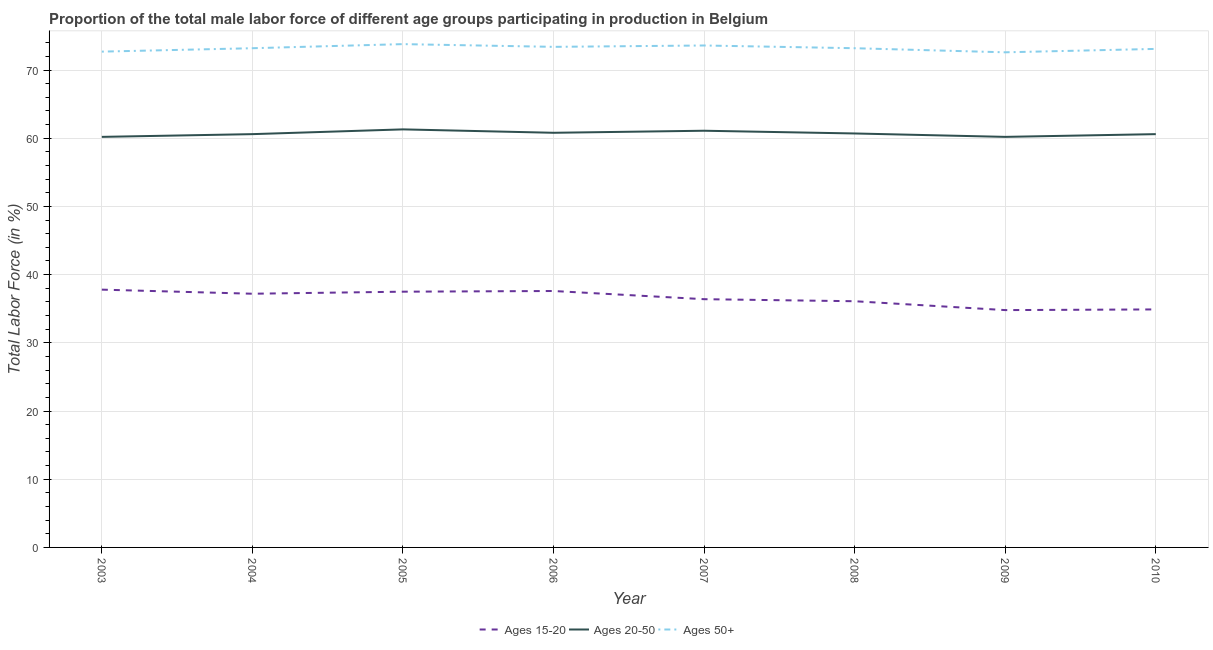How many different coloured lines are there?
Make the answer very short. 3. Does the line corresponding to percentage of male labor force within the age group 15-20 intersect with the line corresponding to percentage of male labor force above age 50?
Give a very brief answer. No. What is the percentage of male labor force above age 50 in 2007?
Ensure brevity in your answer.  73.6. Across all years, what is the maximum percentage of male labor force within the age group 15-20?
Make the answer very short. 37.8. Across all years, what is the minimum percentage of male labor force within the age group 20-50?
Provide a short and direct response. 60.2. In which year was the percentage of male labor force above age 50 maximum?
Give a very brief answer. 2005. What is the total percentage of male labor force within the age group 20-50 in the graph?
Make the answer very short. 485.5. What is the difference between the percentage of male labor force within the age group 20-50 in 2004 and that in 2008?
Your response must be concise. -0.1. What is the difference between the percentage of male labor force within the age group 20-50 in 2010 and the percentage of male labor force above age 50 in 2008?
Your answer should be compact. -12.6. What is the average percentage of male labor force within the age group 15-20 per year?
Ensure brevity in your answer.  36.54. In the year 2004, what is the difference between the percentage of male labor force within the age group 15-20 and percentage of male labor force within the age group 20-50?
Make the answer very short. -23.4. In how many years, is the percentage of male labor force within the age group 20-50 greater than 18 %?
Provide a short and direct response. 8. What is the ratio of the percentage of male labor force within the age group 15-20 in 2008 to that in 2010?
Your response must be concise. 1.03. Is the difference between the percentage of male labor force within the age group 15-20 in 2003 and 2007 greater than the difference between the percentage of male labor force within the age group 20-50 in 2003 and 2007?
Your response must be concise. Yes. What is the difference between the highest and the second highest percentage of male labor force within the age group 20-50?
Offer a very short reply. 0.2. What is the difference between the highest and the lowest percentage of male labor force above age 50?
Your answer should be compact. 1.2. Is the sum of the percentage of male labor force above age 50 in 2004 and 2006 greater than the maximum percentage of male labor force within the age group 20-50 across all years?
Ensure brevity in your answer.  Yes. Is it the case that in every year, the sum of the percentage of male labor force within the age group 15-20 and percentage of male labor force within the age group 20-50 is greater than the percentage of male labor force above age 50?
Ensure brevity in your answer.  Yes. Does the percentage of male labor force within the age group 20-50 monotonically increase over the years?
Provide a short and direct response. No. Is the percentage of male labor force within the age group 20-50 strictly greater than the percentage of male labor force above age 50 over the years?
Your answer should be very brief. No. How many lines are there?
Offer a terse response. 3. Are the values on the major ticks of Y-axis written in scientific E-notation?
Offer a very short reply. No. Does the graph contain any zero values?
Keep it short and to the point. No. Does the graph contain grids?
Make the answer very short. Yes. How are the legend labels stacked?
Offer a terse response. Horizontal. What is the title of the graph?
Provide a succinct answer. Proportion of the total male labor force of different age groups participating in production in Belgium. What is the label or title of the Y-axis?
Offer a very short reply. Total Labor Force (in %). What is the Total Labor Force (in %) of Ages 15-20 in 2003?
Provide a succinct answer. 37.8. What is the Total Labor Force (in %) of Ages 20-50 in 2003?
Your answer should be compact. 60.2. What is the Total Labor Force (in %) in Ages 50+ in 2003?
Your answer should be very brief. 72.7. What is the Total Labor Force (in %) of Ages 15-20 in 2004?
Make the answer very short. 37.2. What is the Total Labor Force (in %) in Ages 20-50 in 2004?
Your answer should be very brief. 60.6. What is the Total Labor Force (in %) in Ages 50+ in 2004?
Your response must be concise. 73.2. What is the Total Labor Force (in %) in Ages 15-20 in 2005?
Offer a terse response. 37.5. What is the Total Labor Force (in %) in Ages 20-50 in 2005?
Offer a very short reply. 61.3. What is the Total Labor Force (in %) of Ages 50+ in 2005?
Your answer should be compact. 73.8. What is the Total Labor Force (in %) of Ages 15-20 in 2006?
Ensure brevity in your answer.  37.6. What is the Total Labor Force (in %) of Ages 20-50 in 2006?
Your response must be concise. 60.8. What is the Total Labor Force (in %) in Ages 50+ in 2006?
Make the answer very short. 73.4. What is the Total Labor Force (in %) of Ages 15-20 in 2007?
Offer a terse response. 36.4. What is the Total Labor Force (in %) in Ages 20-50 in 2007?
Your response must be concise. 61.1. What is the Total Labor Force (in %) in Ages 50+ in 2007?
Ensure brevity in your answer.  73.6. What is the Total Labor Force (in %) of Ages 15-20 in 2008?
Your answer should be very brief. 36.1. What is the Total Labor Force (in %) in Ages 20-50 in 2008?
Your response must be concise. 60.7. What is the Total Labor Force (in %) in Ages 50+ in 2008?
Provide a short and direct response. 73.2. What is the Total Labor Force (in %) of Ages 15-20 in 2009?
Offer a terse response. 34.8. What is the Total Labor Force (in %) in Ages 20-50 in 2009?
Ensure brevity in your answer.  60.2. What is the Total Labor Force (in %) of Ages 50+ in 2009?
Provide a short and direct response. 72.6. What is the Total Labor Force (in %) in Ages 15-20 in 2010?
Offer a terse response. 34.9. What is the Total Labor Force (in %) of Ages 20-50 in 2010?
Offer a terse response. 60.6. What is the Total Labor Force (in %) in Ages 50+ in 2010?
Give a very brief answer. 73.1. Across all years, what is the maximum Total Labor Force (in %) of Ages 15-20?
Your answer should be compact. 37.8. Across all years, what is the maximum Total Labor Force (in %) of Ages 20-50?
Give a very brief answer. 61.3. Across all years, what is the maximum Total Labor Force (in %) in Ages 50+?
Make the answer very short. 73.8. Across all years, what is the minimum Total Labor Force (in %) in Ages 15-20?
Ensure brevity in your answer.  34.8. Across all years, what is the minimum Total Labor Force (in %) of Ages 20-50?
Offer a terse response. 60.2. Across all years, what is the minimum Total Labor Force (in %) in Ages 50+?
Your response must be concise. 72.6. What is the total Total Labor Force (in %) in Ages 15-20 in the graph?
Provide a succinct answer. 292.3. What is the total Total Labor Force (in %) in Ages 20-50 in the graph?
Your answer should be very brief. 485.5. What is the total Total Labor Force (in %) of Ages 50+ in the graph?
Offer a very short reply. 585.6. What is the difference between the Total Labor Force (in %) of Ages 15-20 in 2003 and that in 2004?
Give a very brief answer. 0.6. What is the difference between the Total Labor Force (in %) in Ages 50+ in 2003 and that in 2004?
Make the answer very short. -0.5. What is the difference between the Total Labor Force (in %) in Ages 20-50 in 2003 and that in 2005?
Your response must be concise. -1.1. What is the difference between the Total Labor Force (in %) of Ages 20-50 in 2003 and that in 2006?
Offer a terse response. -0.6. What is the difference between the Total Labor Force (in %) of Ages 50+ in 2003 and that in 2006?
Make the answer very short. -0.7. What is the difference between the Total Labor Force (in %) in Ages 15-20 in 2003 and that in 2007?
Keep it short and to the point. 1.4. What is the difference between the Total Labor Force (in %) of Ages 50+ in 2003 and that in 2007?
Provide a succinct answer. -0.9. What is the difference between the Total Labor Force (in %) of Ages 15-20 in 2003 and that in 2008?
Your answer should be very brief. 1.7. What is the difference between the Total Labor Force (in %) of Ages 50+ in 2003 and that in 2008?
Give a very brief answer. -0.5. What is the difference between the Total Labor Force (in %) in Ages 15-20 in 2003 and that in 2009?
Provide a short and direct response. 3. What is the difference between the Total Labor Force (in %) of Ages 50+ in 2003 and that in 2010?
Your answer should be very brief. -0.4. What is the difference between the Total Labor Force (in %) of Ages 20-50 in 2004 and that in 2006?
Your answer should be compact. -0.2. What is the difference between the Total Labor Force (in %) in Ages 50+ in 2004 and that in 2006?
Give a very brief answer. -0.2. What is the difference between the Total Labor Force (in %) of Ages 15-20 in 2004 and that in 2009?
Offer a terse response. 2.4. What is the difference between the Total Labor Force (in %) of Ages 50+ in 2004 and that in 2009?
Your answer should be compact. 0.6. What is the difference between the Total Labor Force (in %) of Ages 50+ in 2004 and that in 2010?
Offer a terse response. 0.1. What is the difference between the Total Labor Force (in %) in Ages 50+ in 2005 and that in 2007?
Give a very brief answer. 0.2. What is the difference between the Total Labor Force (in %) of Ages 15-20 in 2005 and that in 2008?
Offer a very short reply. 1.4. What is the difference between the Total Labor Force (in %) of Ages 20-50 in 2005 and that in 2009?
Give a very brief answer. 1.1. What is the difference between the Total Labor Force (in %) in Ages 50+ in 2005 and that in 2009?
Ensure brevity in your answer.  1.2. What is the difference between the Total Labor Force (in %) of Ages 15-20 in 2005 and that in 2010?
Provide a succinct answer. 2.6. What is the difference between the Total Labor Force (in %) of Ages 15-20 in 2006 and that in 2007?
Keep it short and to the point. 1.2. What is the difference between the Total Labor Force (in %) in Ages 20-50 in 2006 and that in 2007?
Keep it short and to the point. -0.3. What is the difference between the Total Labor Force (in %) of Ages 50+ in 2006 and that in 2007?
Make the answer very short. -0.2. What is the difference between the Total Labor Force (in %) of Ages 15-20 in 2006 and that in 2009?
Your response must be concise. 2.8. What is the difference between the Total Labor Force (in %) of Ages 50+ in 2006 and that in 2009?
Your answer should be very brief. 0.8. What is the difference between the Total Labor Force (in %) in Ages 50+ in 2006 and that in 2010?
Ensure brevity in your answer.  0.3. What is the difference between the Total Labor Force (in %) of Ages 20-50 in 2007 and that in 2008?
Offer a very short reply. 0.4. What is the difference between the Total Labor Force (in %) in Ages 15-20 in 2007 and that in 2009?
Keep it short and to the point. 1.6. What is the difference between the Total Labor Force (in %) in Ages 20-50 in 2007 and that in 2009?
Offer a terse response. 0.9. What is the difference between the Total Labor Force (in %) of Ages 50+ in 2007 and that in 2009?
Your answer should be very brief. 1. What is the difference between the Total Labor Force (in %) of Ages 20-50 in 2007 and that in 2010?
Give a very brief answer. 0.5. What is the difference between the Total Labor Force (in %) in Ages 50+ in 2007 and that in 2010?
Your answer should be very brief. 0.5. What is the difference between the Total Labor Force (in %) in Ages 20-50 in 2008 and that in 2009?
Ensure brevity in your answer.  0.5. What is the difference between the Total Labor Force (in %) of Ages 50+ in 2008 and that in 2009?
Keep it short and to the point. 0.6. What is the difference between the Total Labor Force (in %) in Ages 15-20 in 2008 and that in 2010?
Your response must be concise. 1.2. What is the difference between the Total Labor Force (in %) of Ages 20-50 in 2008 and that in 2010?
Keep it short and to the point. 0.1. What is the difference between the Total Labor Force (in %) of Ages 50+ in 2008 and that in 2010?
Provide a short and direct response. 0.1. What is the difference between the Total Labor Force (in %) in Ages 15-20 in 2009 and that in 2010?
Offer a very short reply. -0.1. What is the difference between the Total Labor Force (in %) in Ages 15-20 in 2003 and the Total Labor Force (in %) in Ages 20-50 in 2004?
Provide a succinct answer. -22.8. What is the difference between the Total Labor Force (in %) of Ages 15-20 in 2003 and the Total Labor Force (in %) of Ages 50+ in 2004?
Your answer should be very brief. -35.4. What is the difference between the Total Labor Force (in %) of Ages 15-20 in 2003 and the Total Labor Force (in %) of Ages 20-50 in 2005?
Offer a terse response. -23.5. What is the difference between the Total Labor Force (in %) of Ages 15-20 in 2003 and the Total Labor Force (in %) of Ages 50+ in 2005?
Provide a short and direct response. -36. What is the difference between the Total Labor Force (in %) in Ages 15-20 in 2003 and the Total Labor Force (in %) in Ages 20-50 in 2006?
Your answer should be very brief. -23. What is the difference between the Total Labor Force (in %) in Ages 15-20 in 2003 and the Total Labor Force (in %) in Ages 50+ in 2006?
Keep it short and to the point. -35.6. What is the difference between the Total Labor Force (in %) of Ages 20-50 in 2003 and the Total Labor Force (in %) of Ages 50+ in 2006?
Make the answer very short. -13.2. What is the difference between the Total Labor Force (in %) in Ages 15-20 in 2003 and the Total Labor Force (in %) in Ages 20-50 in 2007?
Your response must be concise. -23.3. What is the difference between the Total Labor Force (in %) in Ages 15-20 in 2003 and the Total Labor Force (in %) in Ages 50+ in 2007?
Provide a succinct answer. -35.8. What is the difference between the Total Labor Force (in %) of Ages 15-20 in 2003 and the Total Labor Force (in %) of Ages 20-50 in 2008?
Offer a terse response. -22.9. What is the difference between the Total Labor Force (in %) of Ages 15-20 in 2003 and the Total Labor Force (in %) of Ages 50+ in 2008?
Keep it short and to the point. -35.4. What is the difference between the Total Labor Force (in %) of Ages 20-50 in 2003 and the Total Labor Force (in %) of Ages 50+ in 2008?
Make the answer very short. -13. What is the difference between the Total Labor Force (in %) of Ages 15-20 in 2003 and the Total Labor Force (in %) of Ages 20-50 in 2009?
Offer a very short reply. -22.4. What is the difference between the Total Labor Force (in %) of Ages 15-20 in 2003 and the Total Labor Force (in %) of Ages 50+ in 2009?
Offer a very short reply. -34.8. What is the difference between the Total Labor Force (in %) in Ages 20-50 in 2003 and the Total Labor Force (in %) in Ages 50+ in 2009?
Your answer should be very brief. -12.4. What is the difference between the Total Labor Force (in %) of Ages 15-20 in 2003 and the Total Labor Force (in %) of Ages 20-50 in 2010?
Your answer should be very brief. -22.8. What is the difference between the Total Labor Force (in %) of Ages 15-20 in 2003 and the Total Labor Force (in %) of Ages 50+ in 2010?
Offer a terse response. -35.3. What is the difference between the Total Labor Force (in %) in Ages 20-50 in 2003 and the Total Labor Force (in %) in Ages 50+ in 2010?
Give a very brief answer. -12.9. What is the difference between the Total Labor Force (in %) of Ages 15-20 in 2004 and the Total Labor Force (in %) of Ages 20-50 in 2005?
Provide a succinct answer. -24.1. What is the difference between the Total Labor Force (in %) in Ages 15-20 in 2004 and the Total Labor Force (in %) in Ages 50+ in 2005?
Provide a succinct answer. -36.6. What is the difference between the Total Labor Force (in %) of Ages 15-20 in 2004 and the Total Labor Force (in %) of Ages 20-50 in 2006?
Your answer should be compact. -23.6. What is the difference between the Total Labor Force (in %) of Ages 15-20 in 2004 and the Total Labor Force (in %) of Ages 50+ in 2006?
Keep it short and to the point. -36.2. What is the difference between the Total Labor Force (in %) in Ages 15-20 in 2004 and the Total Labor Force (in %) in Ages 20-50 in 2007?
Make the answer very short. -23.9. What is the difference between the Total Labor Force (in %) of Ages 15-20 in 2004 and the Total Labor Force (in %) of Ages 50+ in 2007?
Offer a very short reply. -36.4. What is the difference between the Total Labor Force (in %) in Ages 15-20 in 2004 and the Total Labor Force (in %) in Ages 20-50 in 2008?
Your response must be concise. -23.5. What is the difference between the Total Labor Force (in %) of Ages 15-20 in 2004 and the Total Labor Force (in %) of Ages 50+ in 2008?
Provide a succinct answer. -36. What is the difference between the Total Labor Force (in %) of Ages 20-50 in 2004 and the Total Labor Force (in %) of Ages 50+ in 2008?
Offer a terse response. -12.6. What is the difference between the Total Labor Force (in %) of Ages 15-20 in 2004 and the Total Labor Force (in %) of Ages 50+ in 2009?
Offer a terse response. -35.4. What is the difference between the Total Labor Force (in %) in Ages 15-20 in 2004 and the Total Labor Force (in %) in Ages 20-50 in 2010?
Give a very brief answer. -23.4. What is the difference between the Total Labor Force (in %) of Ages 15-20 in 2004 and the Total Labor Force (in %) of Ages 50+ in 2010?
Your answer should be compact. -35.9. What is the difference between the Total Labor Force (in %) of Ages 15-20 in 2005 and the Total Labor Force (in %) of Ages 20-50 in 2006?
Your answer should be compact. -23.3. What is the difference between the Total Labor Force (in %) of Ages 15-20 in 2005 and the Total Labor Force (in %) of Ages 50+ in 2006?
Offer a very short reply. -35.9. What is the difference between the Total Labor Force (in %) of Ages 15-20 in 2005 and the Total Labor Force (in %) of Ages 20-50 in 2007?
Keep it short and to the point. -23.6. What is the difference between the Total Labor Force (in %) in Ages 15-20 in 2005 and the Total Labor Force (in %) in Ages 50+ in 2007?
Keep it short and to the point. -36.1. What is the difference between the Total Labor Force (in %) in Ages 15-20 in 2005 and the Total Labor Force (in %) in Ages 20-50 in 2008?
Keep it short and to the point. -23.2. What is the difference between the Total Labor Force (in %) in Ages 15-20 in 2005 and the Total Labor Force (in %) in Ages 50+ in 2008?
Offer a terse response. -35.7. What is the difference between the Total Labor Force (in %) of Ages 20-50 in 2005 and the Total Labor Force (in %) of Ages 50+ in 2008?
Your response must be concise. -11.9. What is the difference between the Total Labor Force (in %) in Ages 15-20 in 2005 and the Total Labor Force (in %) in Ages 20-50 in 2009?
Offer a very short reply. -22.7. What is the difference between the Total Labor Force (in %) of Ages 15-20 in 2005 and the Total Labor Force (in %) of Ages 50+ in 2009?
Offer a very short reply. -35.1. What is the difference between the Total Labor Force (in %) in Ages 15-20 in 2005 and the Total Labor Force (in %) in Ages 20-50 in 2010?
Offer a terse response. -23.1. What is the difference between the Total Labor Force (in %) in Ages 15-20 in 2005 and the Total Labor Force (in %) in Ages 50+ in 2010?
Your answer should be compact. -35.6. What is the difference between the Total Labor Force (in %) of Ages 20-50 in 2005 and the Total Labor Force (in %) of Ages 50+ in 2010?
Keep it short and to the point. -11.8. What is the difference between the Total Labor Force (in %) of Ages 15-20 in 2006 and the Total Labor Force (in %) of Ages 20-50 in 2007?
Keep it short and to the point. -23.5. What is the difference between the Total Labor Force (in %) in Ages 15-20 in 2006 and the Total Labor Force (in %) in Ages 50+ in 2007?
Provide a succinct answer. -36. What is the difference between the Total Labor Force (in %) in Ages 20-50 in 2006 and the Total Labor Force (in %) in Ages 50+ in 2007?
Ensure brevity in your answer.  -12.8. What is the difference between the Total Labor Force (in %) of Ages 15-20 in 2006 and the Total Labor Force (in %) of Ages 20-50 in 2008?
Keep it short and to the point. -23.1. What is the difference between the Total Labor Force (in %) of Ages 15-20 in 2006 and the Total Labor Force (in %) of Ages 50+ in 2008?
Your answer should be compact. -35.6. What is the difference between the Total Labor Force (in %) in Ages 20-50 in 2006 and the Total Labor Force (in %) in Ages 50+ in 2008?
Provide a short and direct response. -12.4. What is the difference between the Total Labor Force (in %) in Ages 15-20 in 2006 and the Total Labor Force (in %) in Ages 20-50 in 2009?
Provide a short and direct response. -22.6. What is the difference between the Total Labor Force (in %) of Ages 15-20 in 2006 and the Total Labor Force (in %) of Ages 50+ in 2009?
Your answer should be very brief. -35. What is the difference between the Total Labor Force (in %) of Ages 20-50 in 2006 and the Total Labor Force (in %) of Ages 50+ in 2009?
Your answer should be very brief. -11.8. What is the difference between the Total Labor Force (in %) in Ages 15-20 in 2006 and the Total Labor Force (in %) in Ages 50+ in 2010?
Keep it short and to the point. -35.5. What is the difference between the Total Labor Force (in %) in Ages 15-20 in 2007 and the Total Labor Force (in %) in Ages 20-50 in 2008?
Your response must be concise. -24.3. What is the difference between the Total Labor Force (in %) of Ages 15-20 in 2007 and the Total Labor Force (in %) of Ages 50+ in 2008?
Provide a short and direct response. -36.8. What is the difference between the Total Labor Force (in %) in Ages 15-20 in 2007 and the Total Labor Force (in %) in Ages 20-50 in 2009?
Give a very brief answer. -23.8. What is the difference between the Total Labor Force (in %) of Ages 15-20 in 2007 and the Total Labor Force (in %) of Ages 50+ in 2009?
Keep it short and to the point. -36.2. What is the difference between the Total Labor Force (in %) in Ages 20-50 in 2007 and the Total Labor Force (in %) in Ages 50+ in 2009?
Make the answer very short. -11.5. What is the difference between the Total Labor Force (in %) of Ages 15-20 in 2007 and the Total Labor Force (in %) of Ages 20-50 in 2010?
Your response must be concise. -24.2. What is the difference between the Total Labor Force (in %) of Ages 15-20 in 2007 and the Total Labor Force (in %) of Ages 50+ in 2010?
Your answer should be very brief. -36.7. What is the difference between the Total Labor Force (in %) in Ages 15-20 in 2008 and the Total Labor Force (in %) in Ages 20-50 in 2009?
Your response must be concise. -24.1. What is the difference between the Total Labor Force (in %) in Ages 15-20 in 2008 and the Total Labor Force (in %) in Ages 50+ in 2009?
Make the answer very short. -36.5. What is the difference between the Total Labor Force (in %) of Ages 15-20 in 2008 and the Total Labor Force (in %) of Ages 20-50 in 2010?
Offer a terse response. -24.5. What is the difference between the Total Labor Force (in %) in Ages 15-20 in 2008 and the Total Labor Force (in %) in Ages 50+ in 2010?
Offer a terse response. -37. What is the difference between the Total Labor Force (in %) in Ages 20-50 in 2008 and the Total Labor Force (in %) in Ages 50+ in 2010?
Give a very brief answer. -12.4. What is the difference between the Total Labor Force (in %) in Ages 15-20 in 2009 and the Total Labor Force (in %) in Ages 20-50 in 2010?
Make the answer very short. -25.8. What is the difference between the Total Labor Force (in %) in Ages 15-20 in 2009 and the Total Labor Force (in %) in Ages 50+ in 2010?
Offer a terse response. -38.3. What is the average Total Labor Force (in %) in Ages 15-20 per year?
Provide a succinct answer. 36.54. What is the average Total Labor Force (in %) of Ages 20-50 per year?
Your answer should be very brief. 60.69. What is the average Total Labor Force (in %) in Ages 50+ per year?
Offer a very short reply. 73.2. In the year 2003, what is the difference between the Total Labor Force (in %) in Ages 15-20 and Total Labor Force (in %) in Ages 20-50?
Your answer should be compact. -22.4. In the year 2003, what is the difference between the Total Labor Force (in %) in Ages 15-20 and Total Labor Force (in %) in Ages 50+?
Offer a terse response. -34.9. In the year 2004, what is the difference between the Total Labor Force (in %) in Ages 15-20 and Total Labor Force (in %) in Ages 20-50?
Offer a very short reply. -23.4. In the year 2004, what is the difference between the Total Labor Force (in %) of Ages 15-20 and Total Labor Force (in %) of Ages 50+?
Offer a terse response. -36. In the year 2005, what is the difference between the Total Labor Force (in %) of Ages 15-20 and Total Labor Force (in %) of Ages 20-50?
Ensure brevity in your answer.  -23.8. In the year 2005, what is the difference between the Total Labor Force (in %) in Ages 15-20 and Total Labor Force (in %) in Ages 50+?
Ensure brevity in your answer.  -36.3. In the year 2005, what is the difference between the Total Labor Force (in %) of Ages 20-50 and Total Labor Force (in %) of Ages 50+?
Your answer should be compact. -12.5. In the year 2006, what is the difference between the Total Labor Force (in %) of Ages 15-20 and Total Labor Force (in %) of Ages 20-50?
Provide a succinct answer. -23.2. In the year 2006, what is the difference between the Total Labor Force (in %) of Ages 15-20 and Total Labor Force (in %) of Ages 50+?
Offer a very short reply. -35.8. In the year 2006, what is the difference between the Total Labor Force (in %) of Ages 20-50 and Total Labor Force (in %) of Ages 50+?
Give a very brief answer. -12.6. In the year 2007, what is the difference between the Total Labor Force (in %) in Ages 15-20 and Total Labor Force (in %) in Ages 20-50?
Offer a terse response. -24.7. In the year 2007, what is the difference between the Total Labor Force (in %) of Ages 15-20 and Total Labor Force (in %) of Ages 50+?
Your response must be concise. -37.2. In the year 2008, what is the difference between the Total Labor Force (in %) in Ages 15-20 and Total Labor Force (in %) in Ages 20-50?
Your response must be concise. -24.6. In the year 2008, what is the difference between the Total Labor Force (in %) of Ages 15-20 and Total Labor Force (in %) of Ages 50+?
Offer a very short reply. -37.1. In the year 2008, what is the difference between the Total Labor Force (in %) in Ages 20-50 and Total Labor Force (in %) in Ages 50+?
Give a very brief answer. -12.5. In the year 2009, what is the difference between the Total Labor Force (in %) of Ages 15-20 and Total Labor Force (in %) of Ages 20-50?
Your answer should be compact. -25.4. In the year 2009, what is the difference between the Total Labor Force (in %) of Ages 15-20 and Total Labor Force (in %) of Ages 50+?
Your answer should be very brief. -37.8. In the year 2009, what is the difference between the Total Labor Force (in %) in Ages 20-50 and Total Labor Force (in %) in Ages 50+?
Your answer should be very brief. -12.4. In the year 2010, what is the difference between the Total Labor Force (in %) in Ages 15-20 and Total Labor Force (in %) in Ages 20-50?
Provide a succinct answer. -25.7. In the year 2010, what is the difference between the Total Labor Force (in %) of Ages 15-20 and Total Labor Force (in %) of Ages 50+?
Keep it short and to the point. -38.2. In the year 2010, what is the difference between the Total Labor Force (in %) of Ages 20-50 and Total Labor Force (in %) of Ages 50+?
Your answer should be compact. -12.5. What is the ratio of the Total Labor Force (in %) of Ages 15-20 in 2003 to that in 2004?
Give a very brief answer. 1.02. What is the ratio of the Total Labor Force (in %) of Ages 20-50 in 2003 to that in 2004?
Keep it short and to the point. 0.99. What is the ratio of the Total Labor Force (in %) of Ages 50+ in 2003 to that in 2004?
Keep it short and to the point. 0.99. What is the ratio of the Total Labor Force (in %) in Ages 15-20 in 2003 to that in 2005?
Your answer should be very brief. 1.01. What is the ratio of the Total Labor Force (in %) in Ages 20-50 in 2003 to that in 2005?
Keep it short and to the point. 0.98. What is the ratio of the Total Labor Force (in %) of Ages 50+ in 2003 to that in 2005?
Keep it short and to the point. 0.99. What is the ratio of the Total Labor Force (in %) of Ages 15-20 in 2003 to that in 2006?
Your answer should be very brief. 1.01. What is the ratio of the Total Labor Force (in %) in Ages 15-20 in 2003 to that in 2007?
Your response must be concise. 1.04. What is the ratio of the Total Labor Force (in %) in Ages 20-50 in 2003 to that in 2007?
Offer a terse response. 0.99. What is the ratio of the Total Labor Force (in %) of Ages 15-20 in 2003 to that in 2008?
Keep it short and to the point. 1.05. What is the ratio of the Total Labor Force (in %) in Ages 20-50 in 2003 to that in 2008?
Offer a terse response. 0.99. What is the ratio of the Total Labor Force (in %) of Ages 50+ in 2003 to that in 2008?
Offer a very short reply. 0.99. What is the ratio of the Total Labor Force (in %) in Ages 15-20 in 2003 to that in 2009?
Keep it short and to the point. 1.09. What is the ratio of the Total Labor Force (in %) in Ages 15-20 in 2003 to that in 2010?
Keep it short and to the point. 1.08. What is the ratio of the Total Labor Force (in %) of Ages 20-50 in 2004 to that in 2005?
Provide a short and direct response. 0.99. What is the ratio of the Total Labor Force (in %) of Ages 50+ in 2004 to that in 2005?
Your response must be concise. 0.99. What is the ratio of the Total Labor Force (in %) in Ages 15-20 in 2004 to that in 2006?
Offer a very short reply. 0.99. What is the ratio of the Total Labor Force (in %) of Ages 50+ in 2004 to that in 2006?
Keep it short and to the point. 1. What is the ratio of the Total Labor Force (in %) in Ages 15-20 in 2004 to that in 2008?
Your response must be concise. 1.03. What is the ratio of the Total Labor Force (in %) in Ages 15-20 in 2004 to that in 2009?
Ensure brevity in your answer.  1.07. What is the ratio of the Total Labor Force (in %) of Ages 20-50 in 2004 to that in 2009?
Your response must be concise. 1.01. What is the ratio of the Total Labor Force (in %) of Ages 50+ in 2004 to that in 2009?
Offer a very short reply. 1.01. What is the ratio of the Total Labor Force (in %) of Ages 15-20 in 2004 to that in 2010?
Give a very brief answer. 1.07. What is the ratio of the Total Labor Force (in %) in Ages 20-50 in 2004 to that in 2010?
Provide a succinct answer. 1. What is the ratio of the Total Labor Force (in %) in Ages 50+ in 2004 to that in 2010?
Your answer should be very brief. 1. What is the ratio of the Total Labor Force (in %) of Ages 20-50 in 2005 to that in 2006?
Ensure brevity in your answer.  1.01. What is the ratio of the Total Labor Force (in %) of Ages 50+ in 2005 to that in 2006?
Make the answer very short. 1.01. What is the ratio of the Total Labor Force (in %) of Ages 15-20 in 2005 to that in 2007?
Provide a succinct answer. 1.03. What is the ratio of the Total Labor Force (in %) of Ages 20-50 in 2005 to that in 2007?
Ensure brevity in your answer.  1. What is the ratio of the Total Labor Force (in %) in Ages 50+ in 2005 to that in 2007?
Provide a short and direct response. 1. What is the ratio of the Total Labor Force (in %) in Ages 15-20 in 2005 to that in 2008?
Provide a short and direct response. 1.04. What is the ratio of the Total Labor Force (in %) in Ages 20-50 in 2005 to that in 2008?
Your response must be concise. 1.01. What is the ratio of the Total Labor Force (in %) of Ages 50+ in 2005 to that in 2008?
Provide a short and direct response. 1.01. What is the ratio of the Total Labor Force (in %) of Ages 15-20 in 2005 to that in 2009?
Provide a succinct answer. 1.08. What is the ratio of the Total Labor Force (in %) in Ages 20-50 in 2005 to that in 2009?
Your answer should be very brief. 1.02. What is the ratio of the Total Labor Force (in %) of Ages 50+ in 2005 to that in 2009?
Your response must be concise. 1.02. What is the ratio of the Total Labor Force (in %) in Ages 15-20 in 2005 to that in 2010?
Provide a short and direct response. 1.07. What is the ratio of the Total Labor Force (in %) in Ages 20-50 in 2005 to that in 2010?
Make the answer very short. 1.01. What is the ratio of the Total Labor Force (in %) in Ages 50+ in 2005 to that in 2010?
Make the answer very short. 1.01. What is the ratio of the Total Labor Force (in %) of Ages 15-20 in 2006 to that in 2007?
Make the answer very short. 1.03. What is the ratio of the Total Labor Force (in %) in Ages 50+ in 2006 to that in 2007?
Make the answer very short. 1. What is the ratio of the Total Labor Force (in %) of Ages 15-20 in 2006 to that in 2008?
Provide a succinct answer. 1.04. What is the ratio of the Total Labor Force (in %) in Ages 15-20 in 2006 to that in 2009?
Give a very brief answer. 1.08. What is the ratio of the Total Labor Force (in %) in Ages 15-20 in 2006 to that in 2010?
Give a very brief answer. 1.08. What is the ratio of the Total Labor Force (in %) of Ages 20-50 in 2006 to that in 2010?
Ensure brevity in your answer.  1. What is the ratio of the Total Labor Force (in %) of Ages 50+ in 2006 to that in 2010?
Your response must be concise. 1. What is the ratio of the Total Labor Force (in %) in Ages 15-20 in 2007 to that in 2008?
Give a very brief answer. 1.01. What is the ratio of the Total Labor Force (in %) of Ages 20-50 in 2007 to that in 2008?
Your answer should be very brief. 1.01. What is the ratio of the Total Labor Force (in %) of Ages 50+ in 2007 to that in 2008?
Provide a short and direct response. 1.01. What is the ratio of the Total Labor Force (in %) of Ages 15-20 in 2007 to that in 2009?
Ensure brevity in your answer.  1.05. What is the ratio of the Total Labor Force (in %) in Ages 20-50 in 2007 to that in 2009?
Offer a terse response. 1.01. What is the ratio of the Total Labor Force (in %) in Ages 50+ in 2007 to that in 2009?
Keep it short and to the point. 1.01. What is the ratio of the Total Labor Force (in %) in Ages 15-20 in 2007 to that in 2010?
Your answer should be compact. 1.04. What is the ratio of the Total Labor Force (in %) in Ages 20-50 in 2007 to that in 2010?
Give a very brief answer. 1.01. What is the ratio of the Total Labor Force (in %) in Ages 50+ in 2007 to that in 2010?
Your answer should be compact. 1.01. What is the ratio of the Total Labor Force (in %) in Ages 15-20 in 2008 to that in 2009?
Offer a very short reply. 1.04. What is the ratio of the Total Labor Force (in %) in Ages 20-50 in 2008 to that in 2009?
Your response must be concise. 1.01. What is the ratio of the Total Labor Force (in %) of Ages 50+ in 2008 to that in 2009?
Your answer should be very brief. 1.01. What is the ratio of the Total Labor Force (in %) in Ages 15-20 in 2008 to that in 2010?
Keep it short and to the point. 1.03. What is the ratio of the Total Labor Force (in %) in Ages 50+ in 2008 to that in 2010?
Keep it short and to the point. 1. What is the difference between the highest and the second highest Total Labor Force (in %) of Ages 15-20?
Your answer should be compact. 0.2. What is the difference between the highest and the second highest Total Labor Force (in %) of Ages 50+?
Provide a short and direct response. 0.2. 